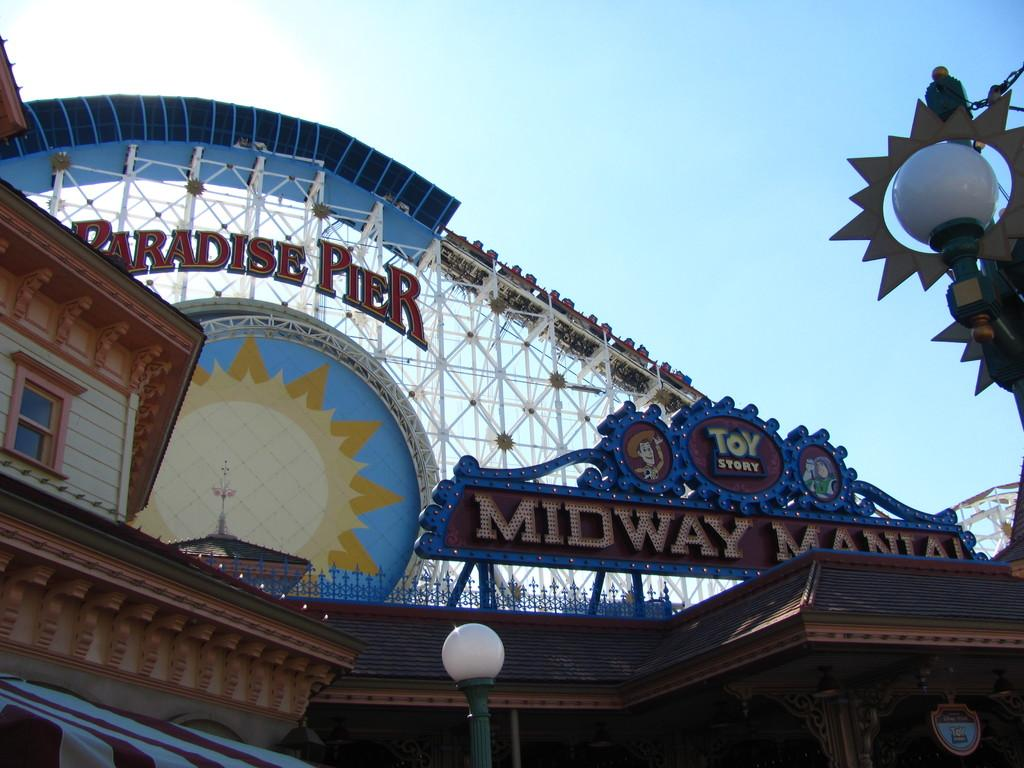<image>
Render a clear and concise summary of the photo. People ride a wooden roller coaster at Paradise Pier. 